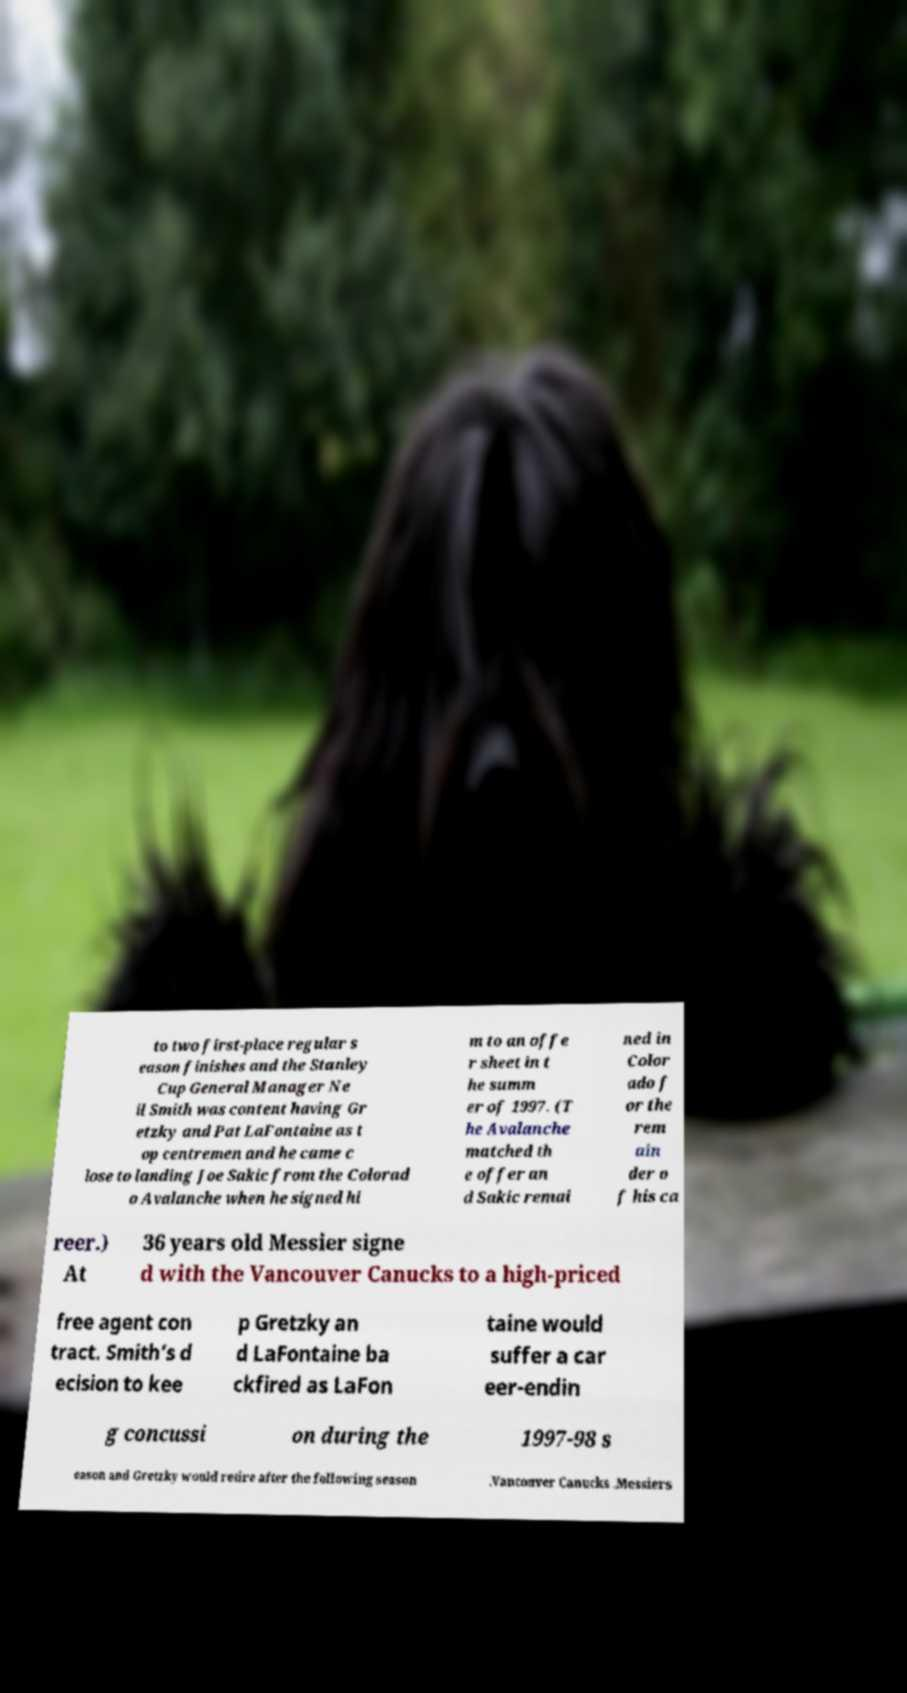Could you assist in decoding the text presented in this image and type it out clearly? to two first-place regular s eason finishes and the Stanley Cup General Manager Ne il Smith was content having Gr etzky and Pat LaFontaine as t op centremen and he came c lose to landing Joe Sakic from the Colorad o Avalanche when he signed hi m to an offe r sheet in t he summ er of 1997. (T he Avalanche matched th e offer an d Sakic remai ned in Color ado f or the rem ain der o f his ca reer.) At 36 years old Messier signe d with the Vancouver Canucks to a high-priced free agent con tract. Smith’s d ecision to kee p Gretzky an d LaFontaine ba ckfired as LaFon taine would suffer a car eer-endin g concussi on during the 1997-98 s eason and Gretzky would retire after the following season .Vancouver Canucks .Messiers 